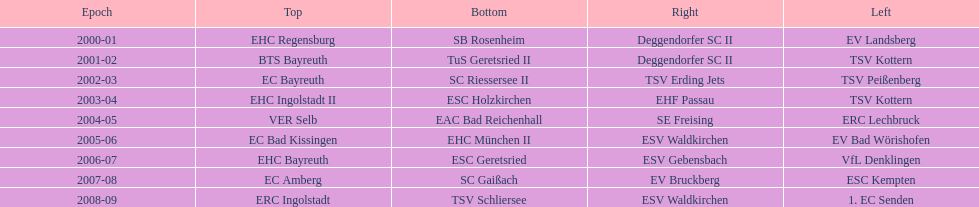Who won the season in the north before ec bayreuth did in 2002-03? BTS Bayreuth. 